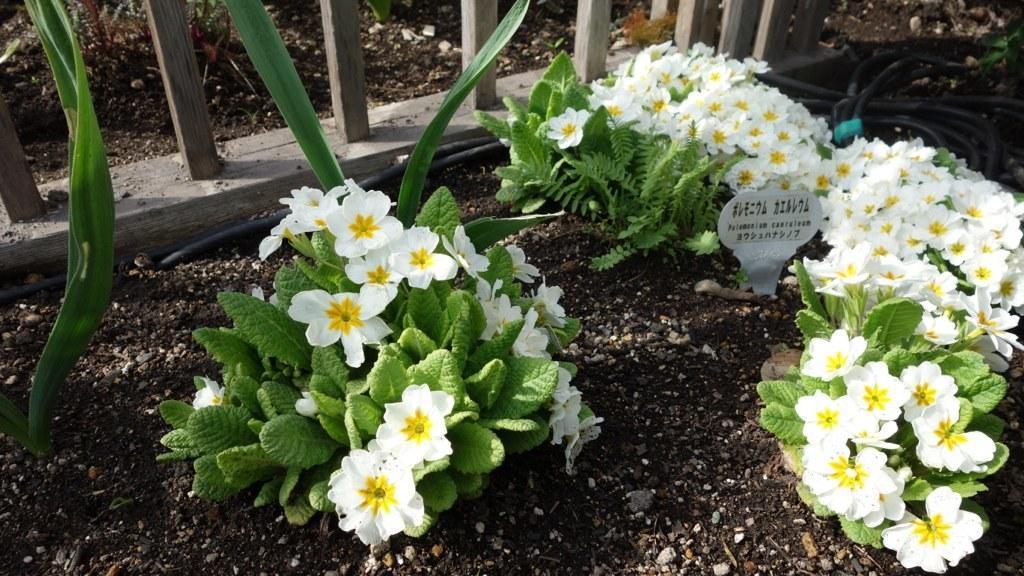Can you describe this image briefly? In the image on the ground there is a black soil with plants and white flowers. At the top right corner of the image there are black wires on the ground. At the top of the image there is a wooden fencing. Behind the fencing there is a soil on the ground. 